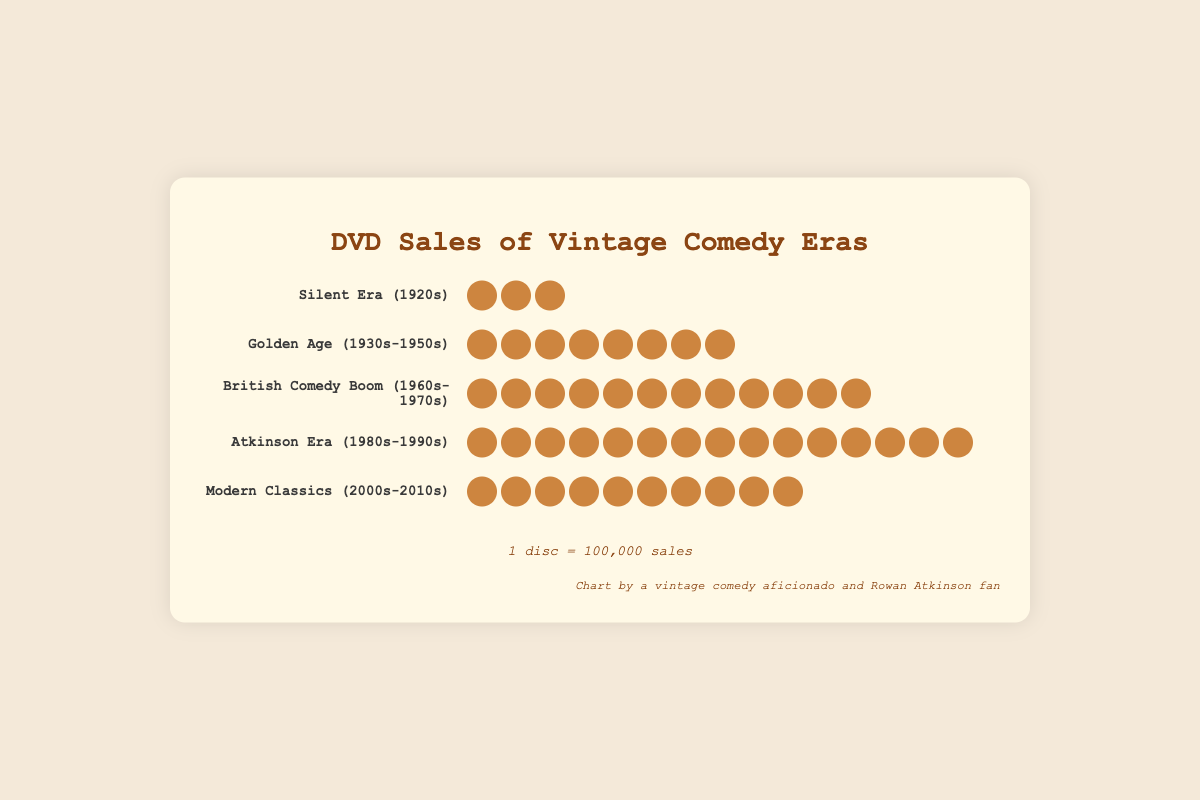What is the title of the figure? The title is usually prominently displayed at the top of the figure. Here, it is "DVD Sales of Vintage Comedy Eras" located above the eras and discs.
Answer: DVD Sales of Vintage Comedy Eras How many sales does the Golden Age (1930s-1950s) era represent in the figure? Each disc icon represents 100,000 sales. The Golden Age era has 8 discs. So, 8 discs x 100,000 sales = 800,000 sales.
Answer: 800,000 Which era has the most DVD sales? By visually comparing the number of disc icons, the Atkinson Era (1980s-1990s) has the most with 15 discs.
Answer: Atkinson Era (1980s-1990s) How does the Modern Classics (2000s-2010s) era's sales compare to the Silent Era (1920s)? The Modern Classics era has 10 discs, and the Silent Era has 3 discs. Therefore, the Modern Classics era has more discs, indicating higher sales.
Answer: Modern Classics has more sales What is the total number of DVD sales represented in the plot? Sum the sales for all eras: Silent Era (3), Golden Age (8), British Comedy Boom (12), Atkinson Era (15), Modern Classics (10). That's (3+8+12+15+10) discs = 48 discs. 48 discs x 100,000 = 4,800,000 sales.
Answer: 4,800,000 Which era's sales are closest to 1,000,000? Each disc represents 100,000 sales. The closest to 10 discs (1,000,000 sales) is the Modern Classics era with 10 discs.
Answer: Modern Classics (2000s-2010s) How many more sales does the Atkinson Era (1980s-1990s) have than the Silent Era (1920s)? Atkinson Era has 15 discs, and Silent Era has 3 discs. The difference is 15 - 3 = 12 discs. So, 12 discs x 100,000 sales = 1,200,000 more sales.
Answer: 1,200,000 What is the average number of discs per era? Total number of discs is 48, and there are 5 eras. The average is 48 discs / 5 eras = 9.6 discs.
Answer: 9.6 discs Arrange the eras in descending order of their DVD sales. Count the discs and order them from most to least: Atkinson Era (15), British Comedy Boom (12), Modern Classics (10), Golden Age (8), Silent Era (3).
Answer: Atkinson Era, British Comedy Boom, Modern Classics, Golden Age, Silent Era 